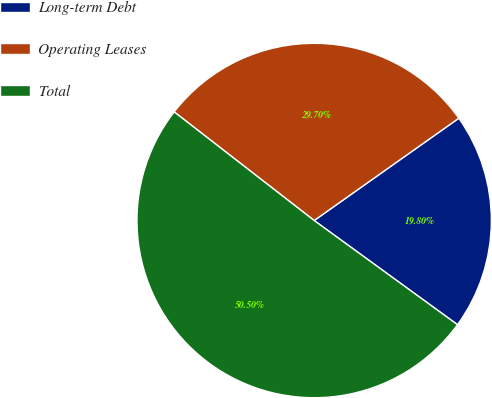<chart> <loc_0><loc_0><loc_500><loc_500><pie_chart><fcel>Long-term Debt<fcel>Operating Leases<fcel>Total<nl><fcel>19.8%<fcel>29.7%<fcel>50.5%<nl></chart> 